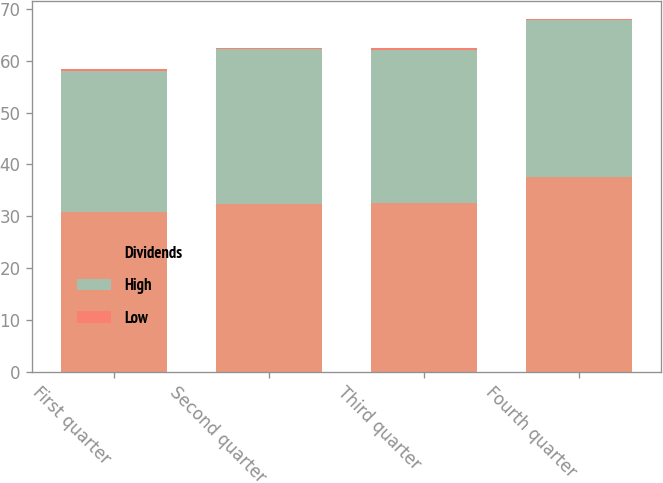Convert chart to OTSL. <chart><loc_0><loc_0><loc_500><loc_500><stacked_bar_chart><ecel><fcel>First quarter<fcel>Second quarter<fcel>Third quarter<fcel>Fourth quarter<nl><fcel>Dividends<fcel>30.77<fcel>32.37<fcel>32.48<fcel>37.58<nl><fcel>High<fcel>27.27<fcel>29.83<fcel>29.6<fcel>30.18<nl><fcel>Low<fcel>0.3<fcel>0.3<fcel>0.3<fcel>0.3<nl></chart> 